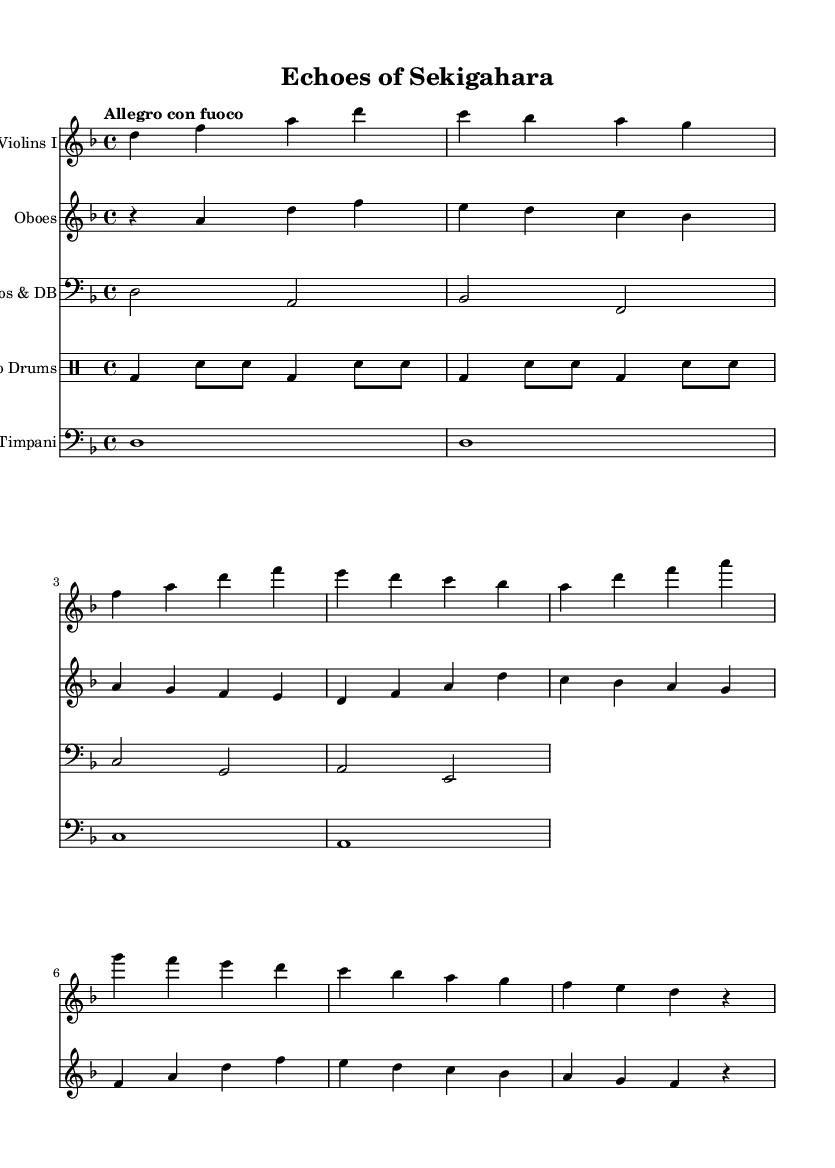What is the key signature of this music? The key signature for this piece, identified by the number of sharps or flats at the beginning of the staff, shows one flat, indicating D minor.
Answer: D minor What is the time signature of this music? The time signature is located at the beginning of the staff, represented by the numbers above it. Here, it reads 4/4, meaning there are four beats in each measure and the quarter note gets one beat.
Answer: 4/4 What is the tempo marking for this piece? The tempo marking is indicated above the staff, stating "Allegro con fuoco," which indicates a fast and lively tempo with fire or passion.
Answer: Allegro con fuoco How many measures are there in the Violins I part? By counting the distinct groups of notes or the bars represented by vertical lines in the Violins I part, there are a total of four measures in this section.
Answer: Four measures What types of instruments are included in this orchestral piece? By observing the different staves labeled at the beginning of each section, the instruments listed are Violins I, Oboes, Cellos & Double Basses, Taiko Drums, and Timpani, indicating a diverse orchestral ensemble.
Answer: Violins, Oboes, Cellos, DB, Taiko Drums, Timpani Which rhythm is used for the Taiko Drums? The rhythm for the Taiko Drums is indicated in the drummode section, which consists of a pattern of bass and snare hits. The pattern shows a repeated sequence of bass drum notes followed by snare drum notes.
Answer: Bass and snare What is the highest pitch in the Oboes part? The pitch of the notes in the Oboes part can be deduced from its relative notation; the highest note in the Oboes part is A, appearing prominently in the second measure.
Answer: A 